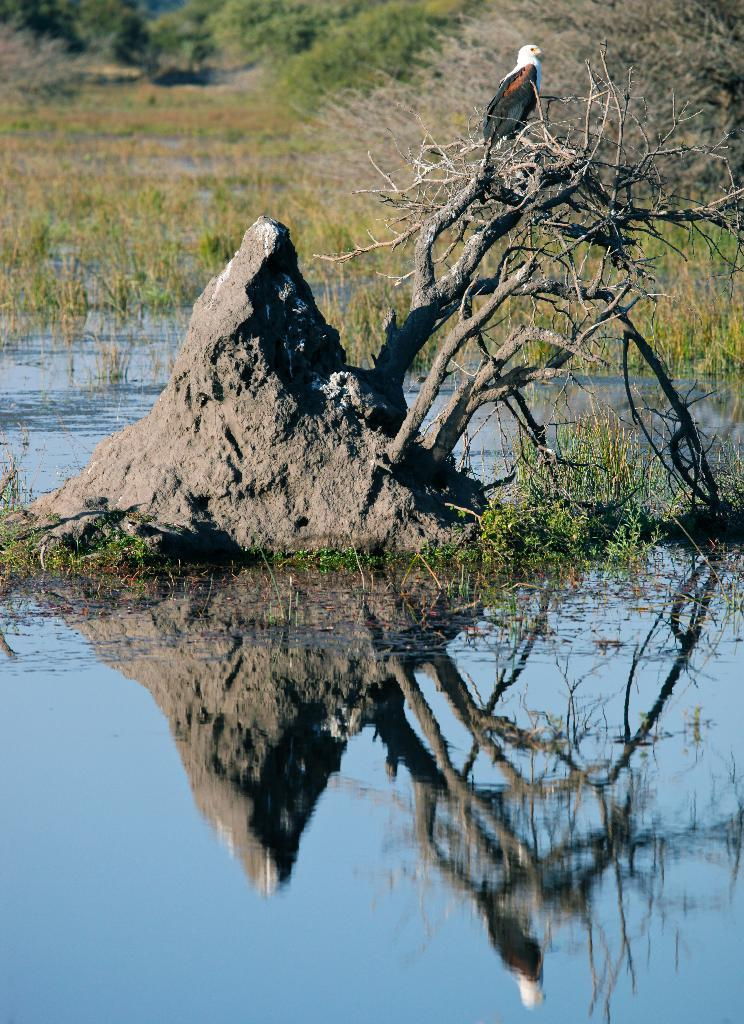What is the primary element visible in the image? There is water in the image. What type of animal can be seen in the image? There is a bird on a plant in the image. What other object is present in the image? There is a rock in the image. What can be seen in the background of the image? There are plants visible in the background of the image. What type of nation is depicted on the gate in the image? There is no gate present in the image, so it is not possible to determine what type of nation might be depicted on it. 